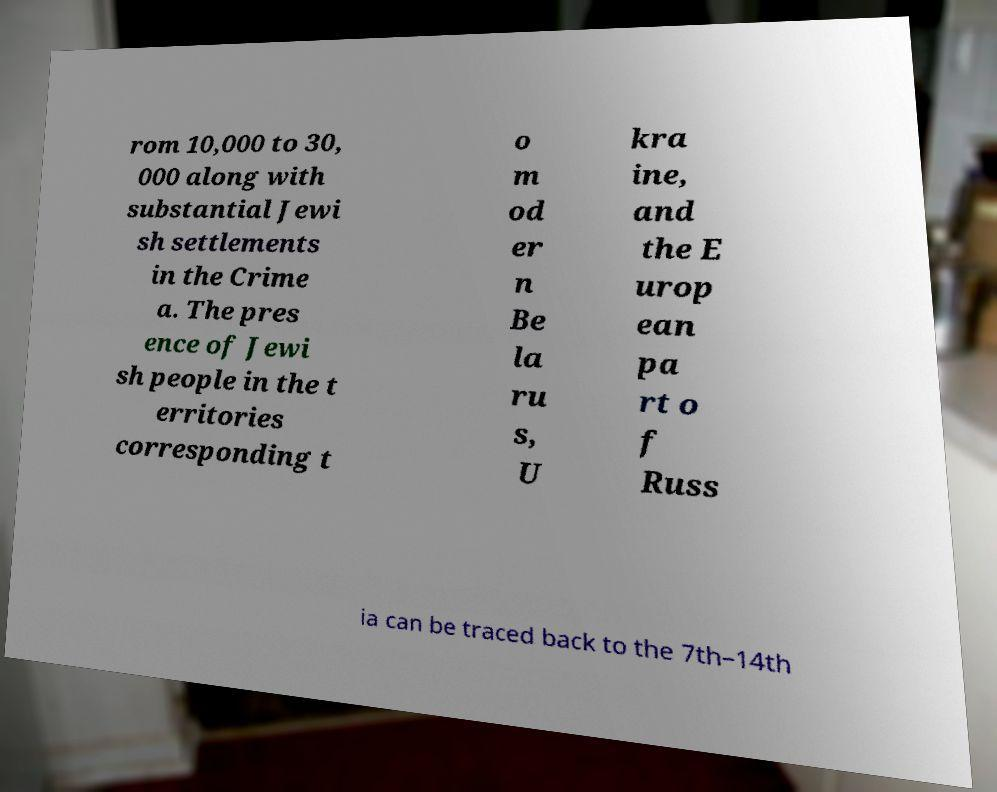Could you extract and type out the text from this image? rom 10,000 to 30, 000 along with substantial Jewi sh settlements in the Crime a. The pres ence of Jewi sh people in the t erritories corresponding t o m od er n Be la ru s, U kra ine, and the E urop ean pa rt o f Russ ia can be traced back to the 7th–14th 